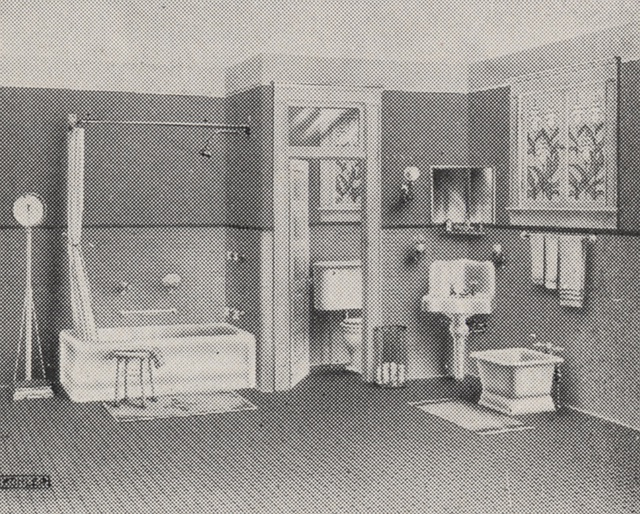Describe the objects in this image and their specific colors. I can see toilet in darkgray, lightgray, and gray tones, sink in darkgray, lightgray, and gray tones, chair in darkgray, gray, and lightgray tones, toilet in darkgray, lightgray, and gray tones, and clock in darkgray and lightgray tones in this image. 